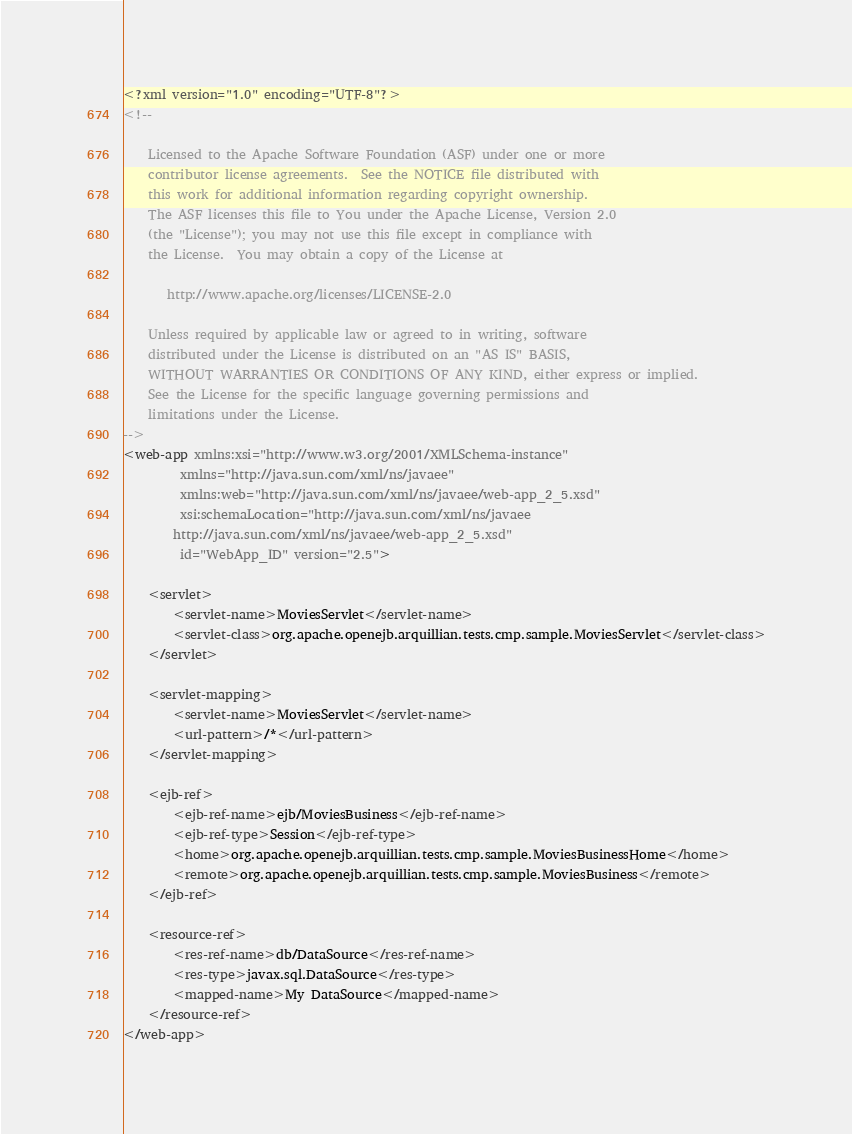<code> <loc_0><loc_0><loc_500><loc_500><_XML_><?xml version="1.0" encoding="UTF-8"?>
<!--

    Licensed to the Apache Software Foundation (ASF) under one or more
    contributor license agreements.  See the NOTICE file distributed with
    this work for additional information regarding copyright ownership.
    The ASF licenses this file to You under the Apache License, Version 2.0
    (the "License"); you may not use this file except in compliance with
    the License.  You may obtain a copy of the License at

       http://www.apache.org/licenses/LICENSE-2.0

    Unless required by applicable law or agreed to in writing, software
    distributed under the License is distributed on an "AS IS" BASIS,
    WITHOUT WARRANTIES OR CONDITIONS OF ANY KIND, either express or implied.
    See the License for the specific language governing permissions and
    limitations under the License.
-->
<web-app xmlns:xsi="http://www.w3.org/2001/XMLSchema-instance"
         xmlns="http://java.sun.com/xml/ns/javaee"
         xmlns:web="http://java.sun.com/xml/ns/javaee/web-app_2_5.xsd"
         xsi:schemaLocation="http://java.sun.com/xml/ns/javaee
        http://java.sun.com/xml/ns/javaee/web-app_2_5.xsd"
         id="WebApp_ID" version="2.5">

    <servlet>
        <servlet-name>MoviesServlet</servlet-name>
        <servlet-class>org.apache.openejb.arquillian.tests.cmp.sample.MoviesServlet</servlet-class>
    </servlet>

    <servlet-mapping>
        <servlet-name>MoviesServlet</servlet-name>
        <url-pattern>/*</url-pattern>
    </servlet-mapping>

    <ejb-ref>
        <ejb-ref-name>ejb/MoviesBusiness</ejb-ref-name>
        <ejb-ref-type>Session</ejb-ref-type>
        <home>org.apache.openejb.arquillian.tests.cmp.sample.MoviesBusinessHome</home>
        <remote>org.apache.openejb.arquillian.tests.cmp.sample.MoviesBusiness</remote>
    </ejb-ref>

    <resource-ref>
        <res-ref-name>db/DataSource</res-ref-name>
        <res-type>javax.sql.DataSource</res-type>
        <mapped-name>My DataSource</mapped-name>
    </resource-ref>
</web-app></code> 